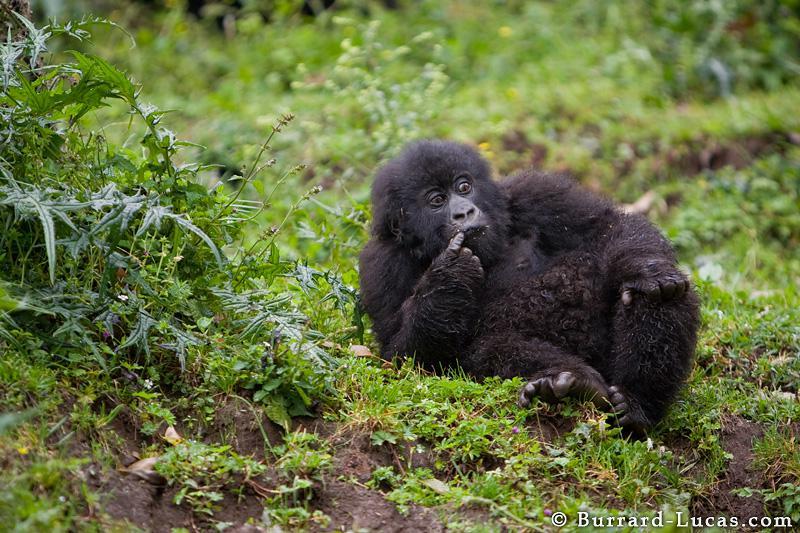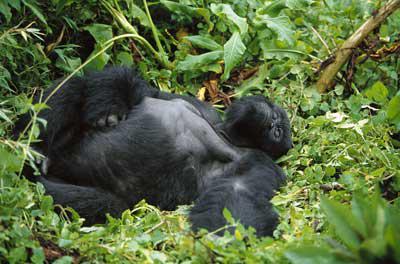The first image is the image on the left, the second image is the image on the right. Examine the images to the left and right. Is the description "Each image shows a single gorilla, and all gorillas are in a reclining pose." accurate? Answer yes or no. Yes. 